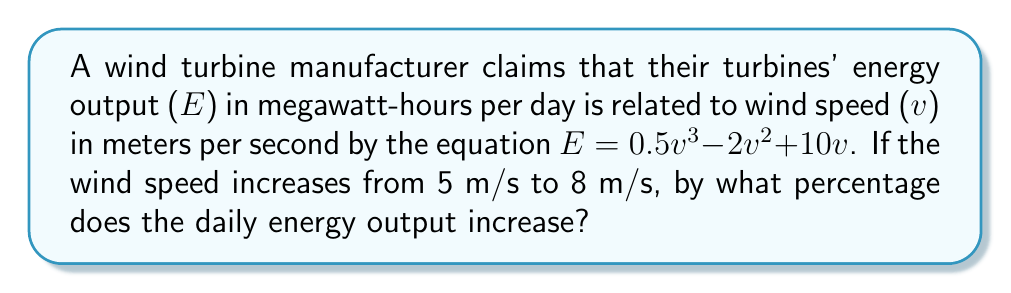Give your solution to this math problem. Let's approach this step-by-step:

1) First, we need to calculate the energy output at 5 m/s:
   $E_5 = 0.5(5^3) - 2(5^2) + 10(5)$
   $= 0.5(125) - 2(25) + 50$
   $= 62.5 - 50 + 50$
   $= 62.5$ MWh/day

2) Now, let's calculate the energy output at 8 m/s:
   $E_8 = 0.5(8^3) - 2(8^2) + 10(8)$
   $= 0.5(512) - 2(64) + 80$
   $= 256 - 128 + 80$
   $= 208$ MWh/day

3) To calculate the percentage increase, we use the formula:
   Percentage increase = $\frac{\text{Increase}}{\text{Original}} \times 100\%$

4) The increase in energy output is:
   $208 - 62.5 = 145.5$ MWh/day

5) Now we can calculate the percentage increase:
   Percentage increase = $\frac{145.5}{62.5} \times 100\%$
   $= 2.328 \times 100\%$
   $= 232.8\%$

Therefore, the daily energy output increases by approximately 232.8% when the wind speed increases from 5 m/s to 8 m/s.
Answer: 232.8% 